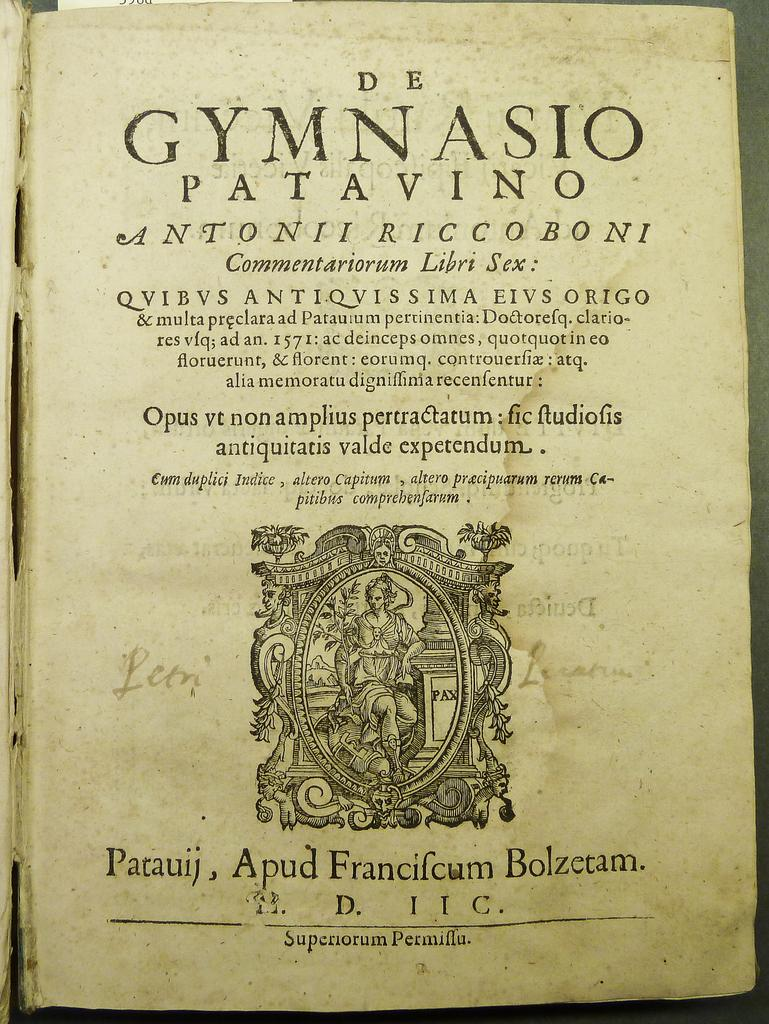<image>
Relay a brief, clear account of the picture shown. The cover page of the text "De Gymnasio patavino" with an illustration at the bottom. 